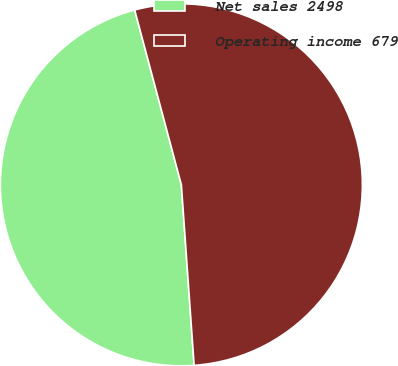<chart> <loc_0><loc_0><loc_500><loc_500><pie_chart><fcel>Net sales 2498<fcel>Operating income 679<nl><fcel>46.97%<fcel>53.03%<nl></chart> 